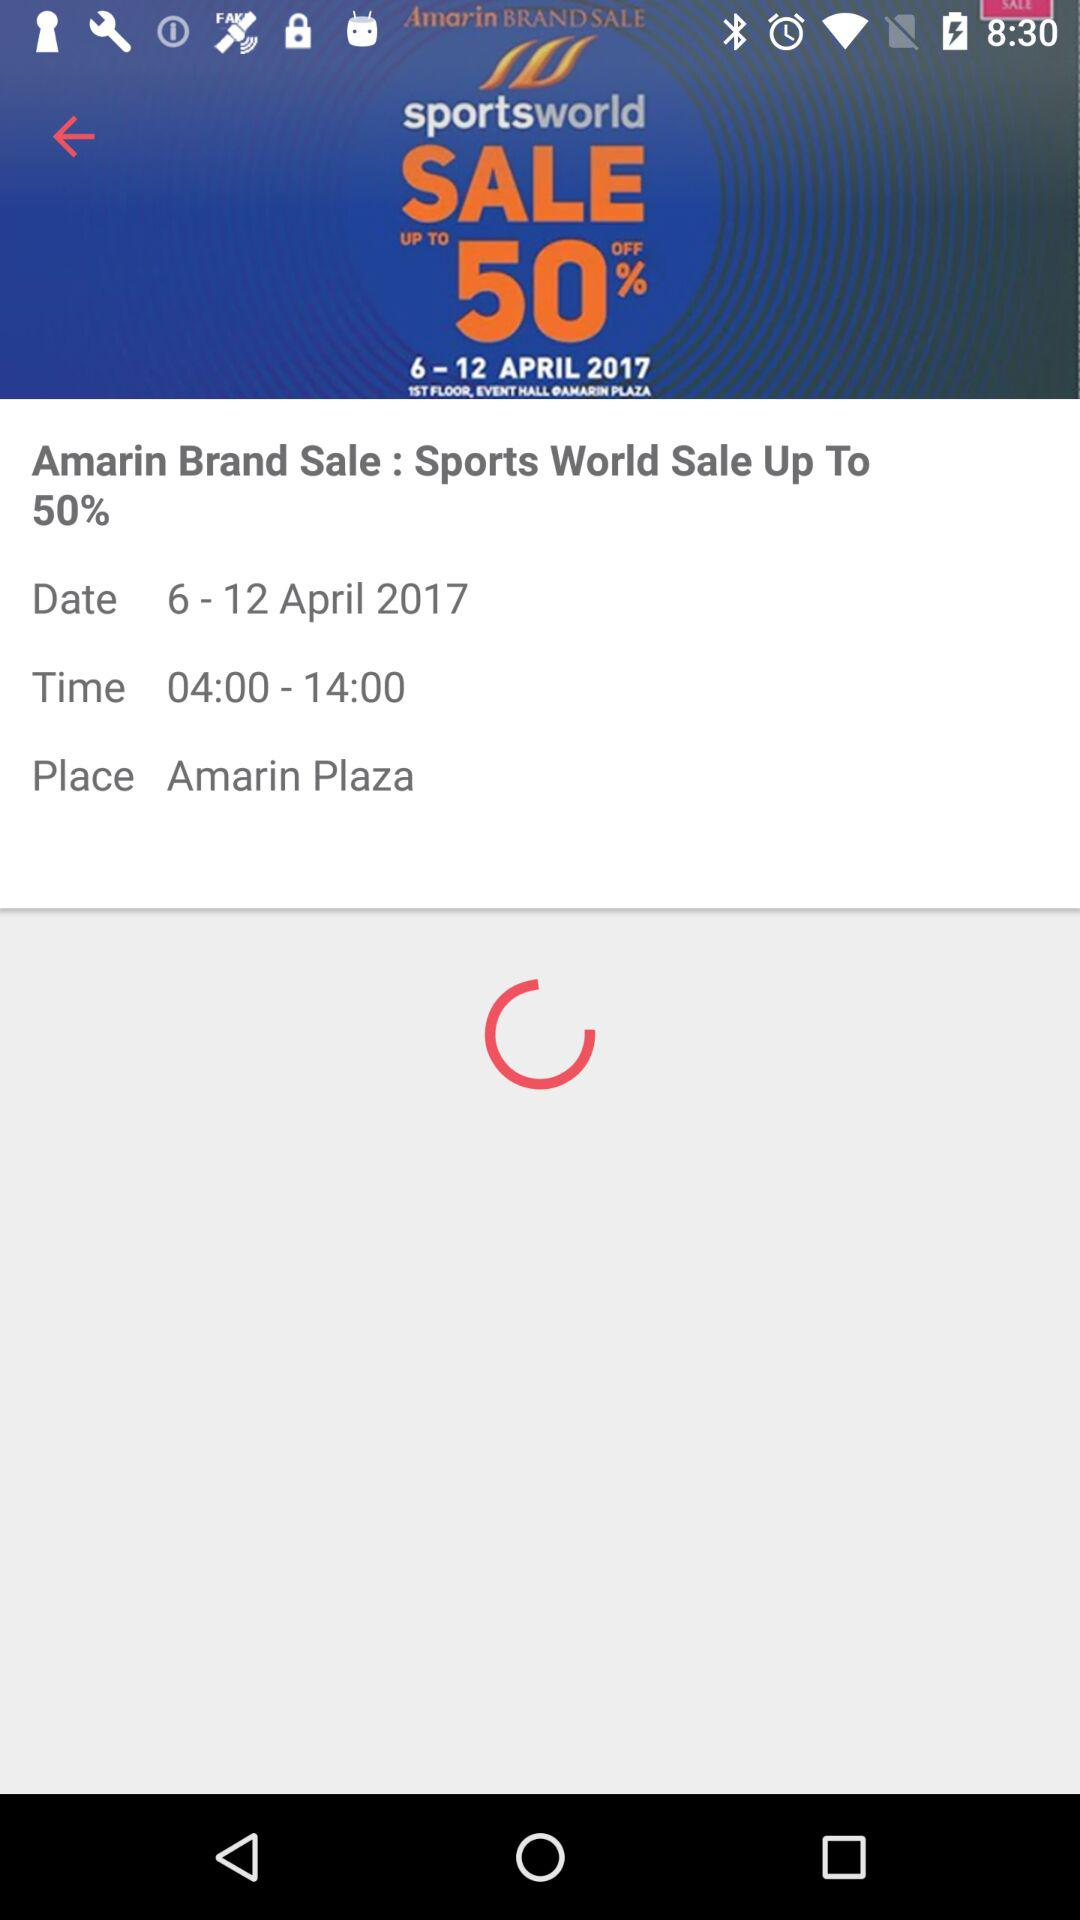What is the brand name? The brand name is "Amarin". 